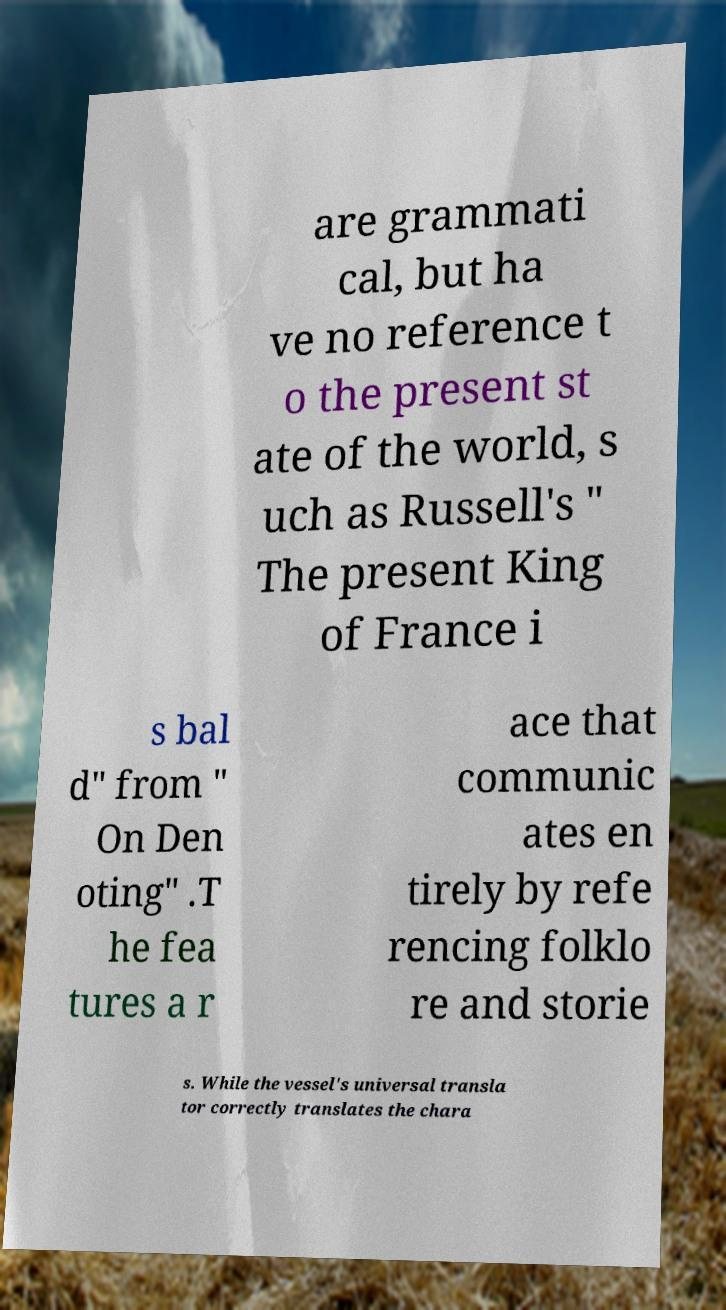There's text embedded in this image that I need extracted. Can you transcribe it verbatim? are grammati cal, but ha ve no reference t o the present st ate of the world, s uch as Russell's " The present King of France i s bal d" from " On Den oting" .T he fea tures a r ace that communic ates en tirely by refe rencing folklo re and storie s. While the vessel's universal transla tor correctly translates the chara 